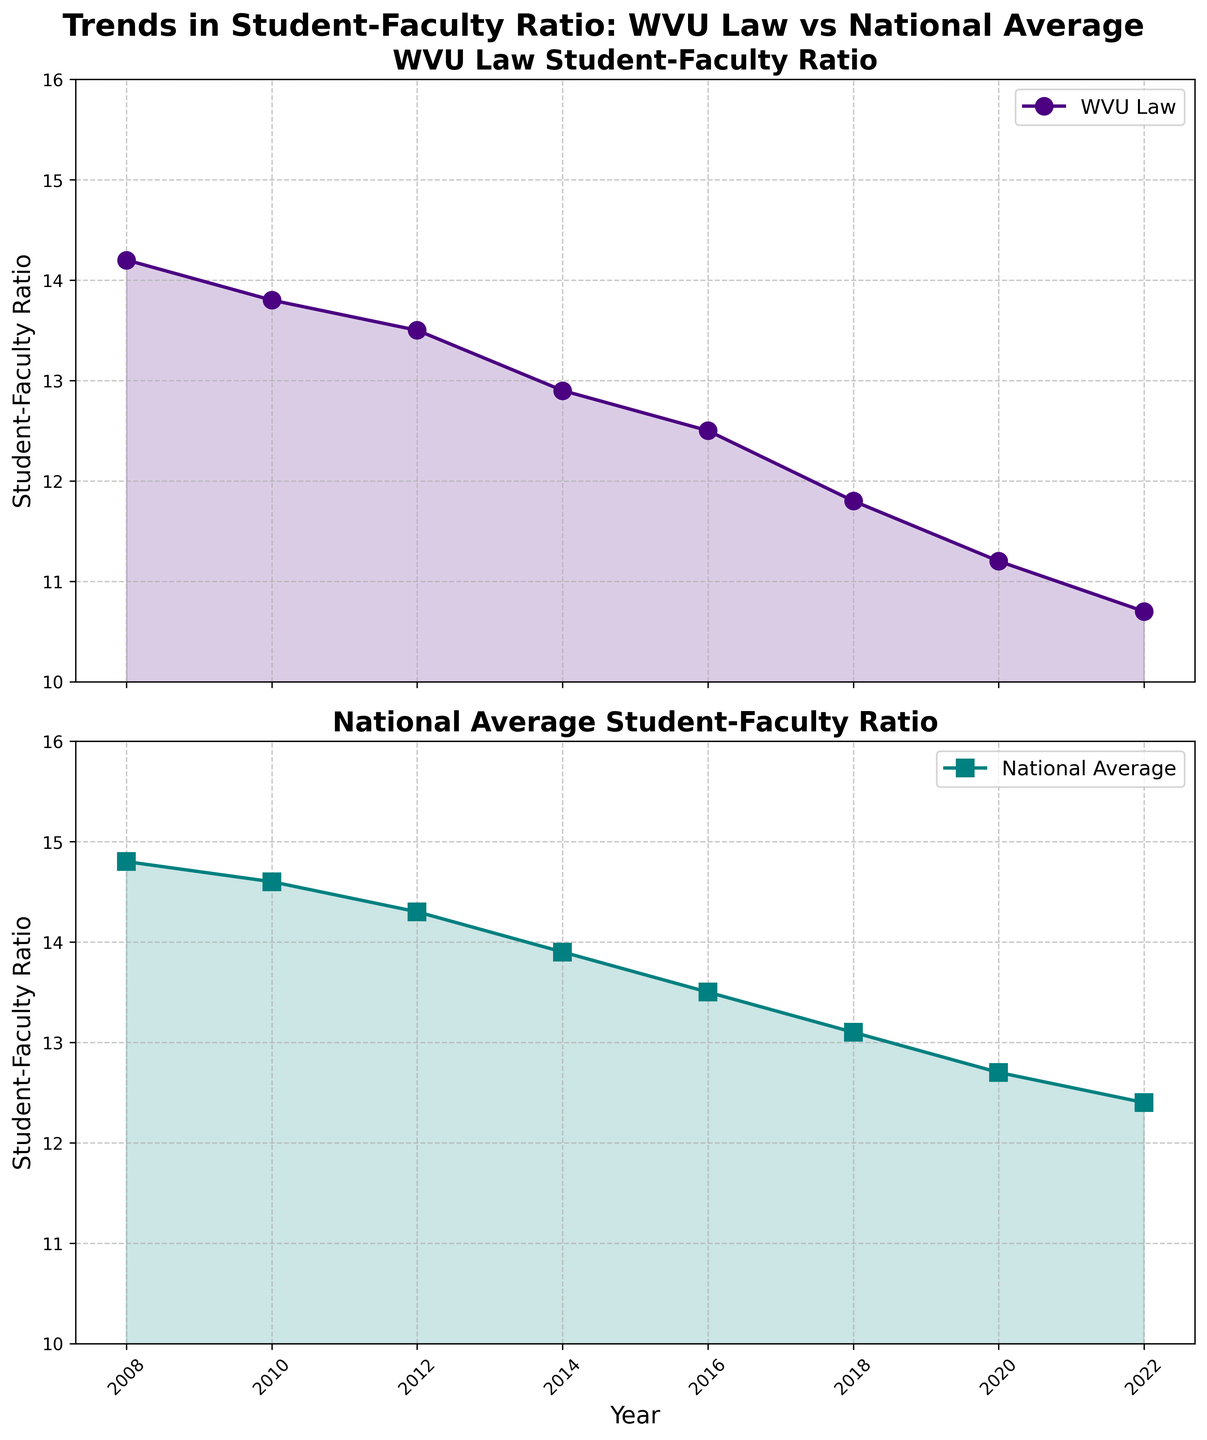What is the title of the figure? The title of the figure is located at the top center, summarizing the main subject of the figure. The title reads "Trends in Student-Faculty Ratio: WVU Law vs National Average."
Answer: Trends in Student-Faculty Ratio: WVU Law vs National Average What year had the highest student-faculty ratio for WVU Law? Refer to the WVU Law subplot. The data points reach a maximum in 2008, which indicates the highest student-faculty ratio for WVU Law.
Answer: 2008 Is the student-faculty ratio trend for WVU Law increasing or decreasing over the years? Look at the slope of the line in the WVU Law subplot. The trend slopes downward from 2008 to 2022, indicating a decrease.
Answer: Decreasing In what year did the national average student-faculty ratio first drop below 14? Examine the national average subplot. The national ratio first drops below 14 between 2012 and 2014. Therefore, the correct year is 2014.
Answer: 2014 Compare the WVU Law student-faculty ratio to the national average in 2016. Which is higher? Look at both subplots for the year 2016. WVU Law has a ratio of 12.5, whereas the national average is 13.5. Thus, the national average is higher.
Answer: National average How much did the WVU Law student-faculty ratio change from 2008 to 2022? Subtract the ratio in 2022 (10.7) from the ratio in 2008 (14.2). The change is 14.2 - 10.7.
Answer: 3.5 What is the average student-faculty ratio for WVU Law over the years displayed? Add all the values of WVU Law's student-faculty ratios and divide by the number of years. (14.2 + 13.8 + 13.5 + 12.9 + 12.5 + 11.8 + 11.2 + 10.7) / 8 = 12.575
Answer: 12.575 Which subplot has a brighter color used for marking the data points? The subplot for the national average uses a brighter color (teal) compared to the darker color (indigo) used in the WVU Law subplot.
Answer: National average Between which consecutive years did WVU Law see the most significant drop in student-faculty ratio? Compare the differences between consecutive years in the WVU Law subplot. The largest drop occurs between 2018 (11.8) to 2020 (11.2), which is 0.6.
Answer: 2018 to 2020 On average, is the national student-faculty ratio higher than the WVU Law student-faculty ratio? Calculate the average for both ratios. WVU Law's average is 12.575, and the national average student-faculty ratio by summing (14.8 + 14.6 + 14.3 + 13.9 + 13.5 + 13.1 + 12.7 + 12.4) / 8 = 13.7875. 13.7875 is greater than 12.575.
Answer: Yes 